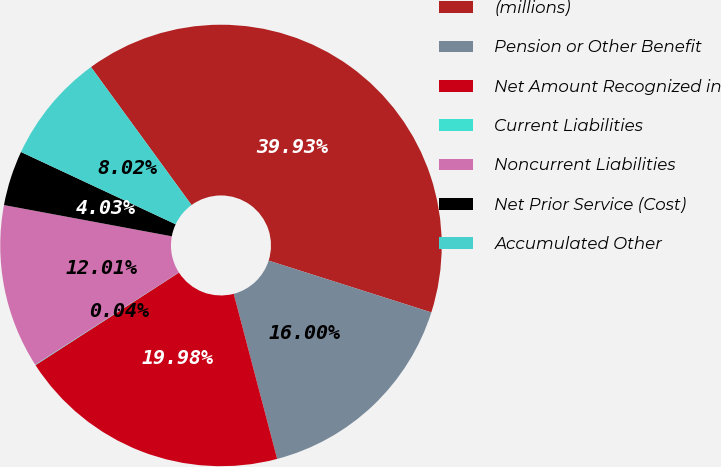Convert chart to OTSL. <chart><loc_0><loc_0><loc_500><loc_500><pie_chart><fcel>(millions)<fcel>Pension or Other Benefit<fcel>Net Amount Recognized in<fcel>Current Liabilities<fcel>Noncurrent Liabilities<fcel>Net Prior Service (Cost)<fcel>Accumulated Other<nl><fcel>39.93%<fcel>16.0%<fcel>19.98%<fcel>0.04%<fcel>12.01%<fcel>4.03%<fcel>8.02%<nl></chart> 